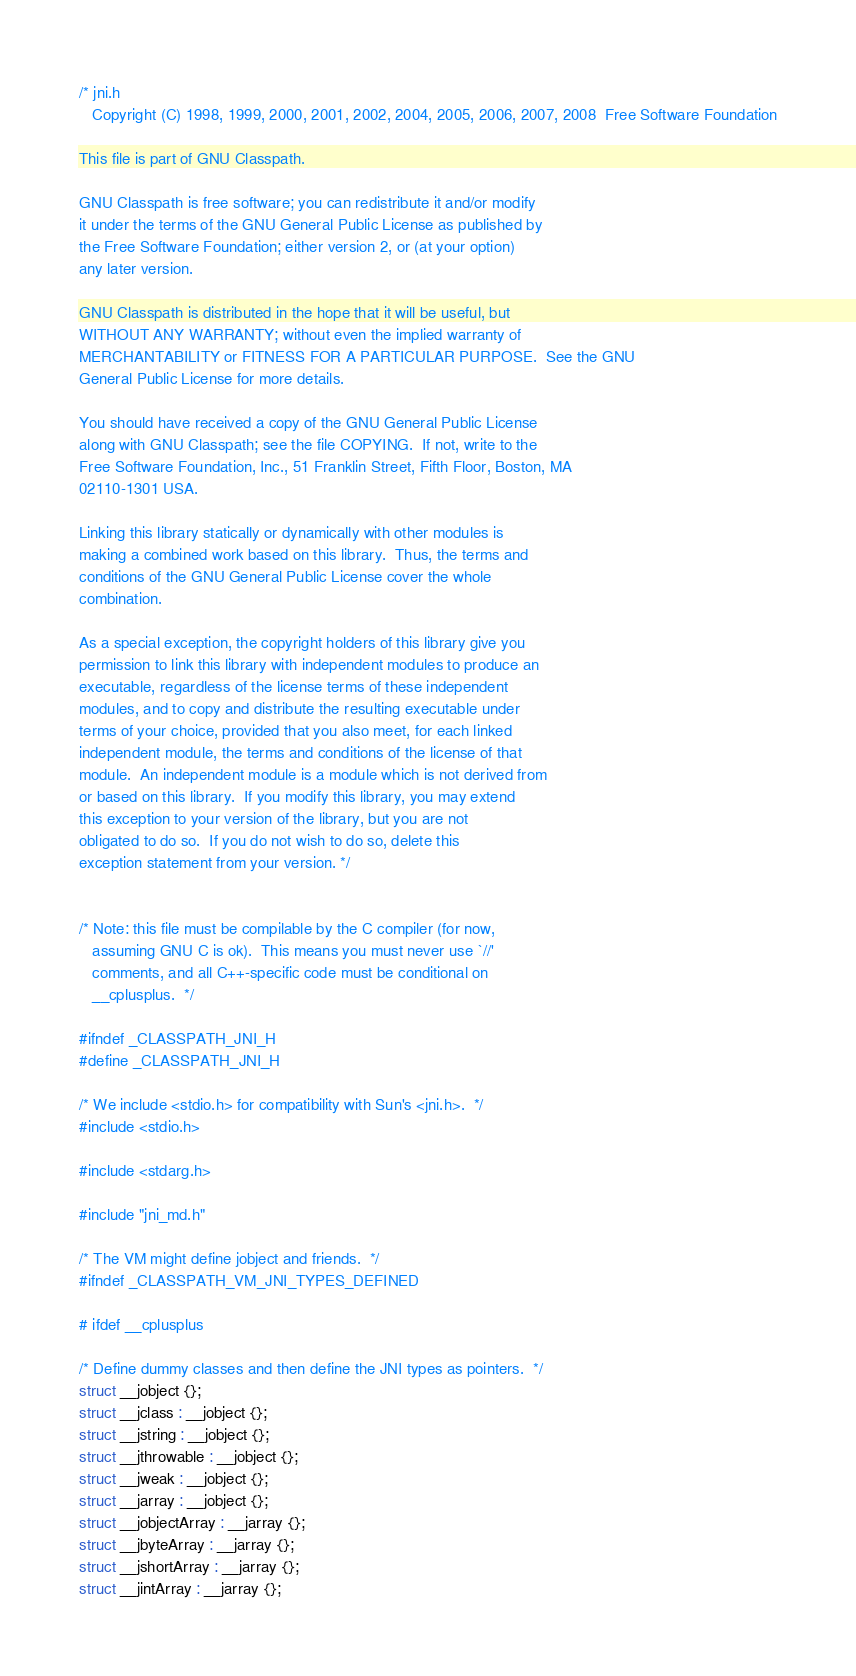Convert code to text. <code><loc_0><loc_0><loc_500><loc_500><_C_>/* jni.h
   Copyright (C) 1998, 1999, 2000, 2001, 2002, 2004, 2005, 2006, 2007, 2008  Free Software Foundation

This file is part of GNU Classpath.

GNU Classpath is free software; you can redistribute it and/or modify
it under the terms of the GNU General Public License as published by
the Free Software Foundation; either version 2, or (at your option)
any later version.
 
GNU Classpath is distributed in the hope that it will be useful, but
WITHOUT ANY WARRANTY; without even the implied warranty of
MERCHANTABILITY or FITNESS FOR A PARTICULAR PURPOSE.  See the GNU
General Public License for more details.

You should have received a copy of the GNU General Public License
along with GNU Classpath; see the file COPYING.  If not, write to the
Free Software Foundation, Inc., 51 Franklin Street, Fifth Floor, Boston, MA
02110-1301 USA.

Linking this library statically or dynamically with other modules is
making a combined work based on this library.  Thus, the terms and
conditions of the GNU General Public License cover the whole
combination.

As a special exception, the copyright holders of this library give you
permission to link this library with independent modules to produce an
executable, regardless of the license terms of these independent
modules, and to copy and distribute the resulting executable under
terms of your choice, provided that you also meet, for each linked
independent module, the terms and conditions of the license of that
module.  An independent module is a module which is not derived from
or based on this library.  If you modify this library, you may extend
this exception to your version of the library, but you are not
obligated to do so.  If you do not wish to do so, delete this
exception statement from your version. */


/* Note: this file must be compilable by the C compiler (for now,
   assuming GNU C is ok).  This means you must never use `//'
   comments, and all C++-specific code must be conditional on
   __cplusplus.  */

#ifndef _CLASSPATH_JNI_H
#define _CLASSPATH_JNI_H

/* We include <stdio.h> for compatibility with Sun's <jni.h>.  */
#include <stdio.h>

#include <stdarg.h>

#include "jni_md.h"

/* The VM might define jobject and friends.  */
#ifndef _CLASSPATH_VM_JNI_TYPES_DEFINED

# ifdef __cplusplus

/* Define dummy classes and then define the JNI types as pointers.  */
struct __jobject {};
struct __jclass : __jobject {};
struct __jstring : __jobject {};
struct __jthrowable : __jobject {};
struct __jweak : __jobject {};
struct __jarray : __jobject {};
struct __jobjectArray : __jarray {};
struct __jbyteArray : __jarray {};
struct __jshortArray : __jarray {};
struct __jintArray : __jarray {};</code> 